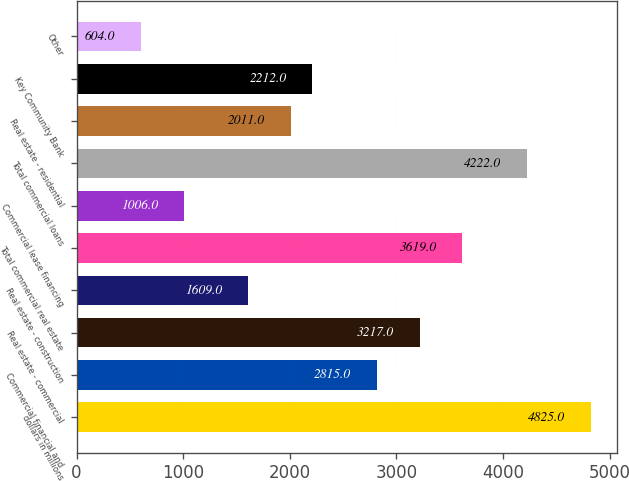Convert chart. <chart><loc_0><loc_0><loc_500><loc_500><bar_chart><fcel>dollars in millions<fcel>Commercial financial and<fcel>Real estate - commercial<fcel>Real estate - construction<fcel>Total commercial real estate<fcel>Commercial lease financing<fcel>Total commercial loans<fcel>Real estate - residential<fcel>Key Community Bank<fcel>Other<nl><fcel>4825<fcel>2815<fcel>3217<fcel>1609<fcel>3619<fcel>1006<fcel>4222<fcel>2011<fcel>2212<fcel>604<nl></chart> 